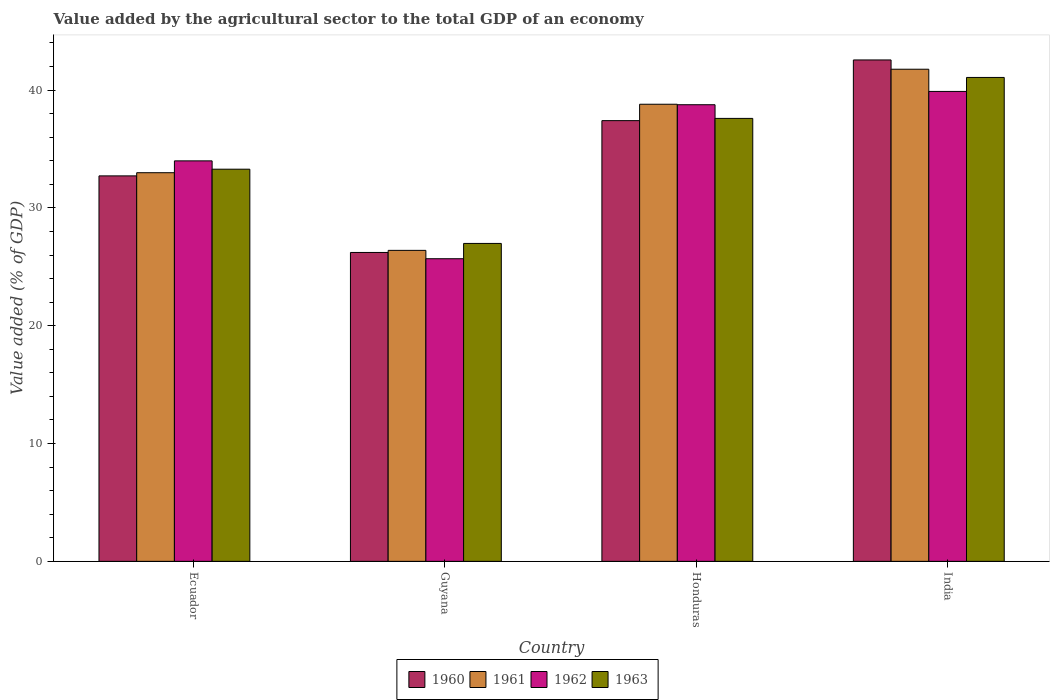How many different coloured bars are there?
Your response must be concise. 4. How many groups of bars are there?
Provide a short and direct response. 4. Are the number of bars on each tick of the X-axis equal?
Provide a succinct answer. Yes. How many bars are there on the 3rd tick from the left?
Make the answer very short. 4. What is the label of the 2nd group of bars from the left?
Provide a succinct answer. Guyana. What is the value added by the agricultural sector to the total GDP in 1963 in Ecuador?
Provide a short and direct response. 33.29. Across all countries, what is the maximum value added by the agricultural sector to the total GDP in 1963?
Your answer should be very brief. 41.08. Across all countries, what is the minimum value added by the agricultural sector to the total GDP in 1963?
Give a very brief answer. 26.99. In which country was the value added by the agricultural sector to the total GDP in 1962 maximum?
Provide a succinct answer. India. In which country was the value added by the agricultural sector to the total GDP in 1962 minimum?
Provide a short and direct response. Guyana. What is the total value added by the agricultural sector to the total GDP in 1962 in the graph?
Keep it short and to the point. 138.33. What is the difference between the value added by the agricultural sector to the total GDP in 1961 in Guyana and that in India?
Your answer should be very brief. -15.38. What is the difference between the value added by the agricultural sector to the total GDP in 1963 in Guyana and the value added by the agricultural sector to the total GDP in 1960 in Ecuador?
Keep it short and to the point. -5.73. What is the average value added by the agricultural sector to the total GDP in 1961 per country?
Make the answer very short. 34.99. What is the difference between the value added by the agricultural sector to the total GDP of/in 1961 and value added by the agricultural sector to the total GDP of/in 1960 in Honduras?
Your answer should be very brief. 1.39. What is the ratio of the value added by the agricultural sector to the total GDP in 1961 in Ecuador to that in India?
Your response must be concise. 0.79. Is the value added by the agricultural sector to the total GDP in 1962 in Guyana less than that in Honduras?
Your answer should be very brief. Yes. Is the difference between the value added by the agricultural sector to the total GDP in 1961 in Guyana and Honduras greater than the difference between the value added by the agricultural sector to the total GDP in 1960 in Guyana and Honduras?
Give a very brief answer. No. What is the difference between the highest and the second highest value added by the agricultural sector to the total GDP in 1961?
Your answer should be very brief. -8.78. What is the difference between the highest and the lowest value added by the agricultural sector to the total GDP in 1961?
Your answer should be very brief. 15.38. Is the sum of the value added by the agricultural sector to the total GDP in 1960 in Guyana and Honduras greater than the maximum value added by the agricultural sector to the total GDP in 1963 across all countries?
Ensure brevity in your answer.  Yes. Is it the case that in every country, the sum of the value added by the agricultural sector to the total GDP in 1961 and value added by the agricultural sector to the total GDP in 1963 is greater than the sum of value added by the agricultural sector to the total GDP in 1960 and value added by the agricultural sector to the total GDP in 1962?
Your answer should be compact. No. What does the 1st bar from the right in Honduras represents?
Offer a terse response. 1963. Is it the case that in every country, the sum of the value added by the agricultural sector to the total GDP in 1962 and value added by the agricultural sector to the total GDP in 1961 is greater than the value added by the agricultural sector to the total GDP in 1963?
Offer a terse response. Yes. Are all the bars in the graph horizontal?
Make the answer very short. No. How many countries are there in the graph?
Your response must be concise. 4. Are the values on the major ticks of Y-axis written in scientific E-notation?
Offer a very short reply. No. Does the graph contain grids?
Provide a succinct answer. No. Where does the legend appear in the graph?
Make the answer very short. Bottom center. What is the title of the graph?
Your answer should be very brief. Value added by the agricultural sector to the total GDP of an economy. Does "1986" appear as one of the legend labels in the graph?
Offer a very short reply. No. What is the label or title of the X-axis?
Keep it short and to the point. Country. What is the label or title of the Y-axis?
Keep it short and to the point. Value added (% of GDP). What is the Value added (% of GDP) of 1960 in Ecuador?
Your response must be concise. 32.72. What is the Value added (% of GDP) of 1961 in Ecuador?
Provide a short and direct response. 32.99. What is the Value added (% of GDP) in 1962 in Ecuador?
Your answer should be very brief. 33.99. What is the Value added (% of GDP) in 1963 in Ecuador?
Make the answer very short. 33.29. What is the Value added (% of GDP) in 1960 in Guyana?
Make the answer very short. 26.22. What is the Value added (% of GDP) of 1961 in Guyana?
Your response must be concise. 26.4. What is the Value added (% of GDP) in 1962 in Guyana?
Provide a succinct answer. 25.69. What is the Value added (% of GDP) of 1963 in Guyana?
Offer a very short reply. 26.99. What is the Value added (% of GDP) in 1960 in Honduras?
Your answer should be compact. 37.41. What is the Value added (% of GDP) in 1961 in Honduras?
Provide a succinct answer. 38.8. What is the Value added (% of GDP) in 1962 in Honduras?
Give a very brief answer. 38.76. What is the Value added (% of GDP) of 1963 in Honduras?
Make the answer very short. 37.6. What is the Value added (% of GDP) of 1960 in India?
Give a very brief answer. 42.56. What is the Value added (% of GDP) in 1961 in India?
Your response must be concise. 41.77. What is the Value added (% of GDP) in 1962 in India?
Your answer should be very brief. 39.89. What is the Value added (% of GDP) in 1963 in India?
Your response must be concise. 41.08. Across all countries, what is the maximum Value added (% of GDP) in 1960?
Your answer should be compact. 42.56. Across all countries, what is the maximum Value added (% of GDP) in 1961?
Make the answer very short. 41.77. Across all countries, what is the maximum Value added (% of GDP) of 1962?
Offer a terse response. 39.89. Across all countries, what is the maximum Value added (% of GDP) of 1963?
Provide a short and direct response. 41.08. Across all countries, what is the minimum Value added (% of GDP) in 1960?
Your response must be concise. 26.22. Across all countries, what is the minimum Value added (% of GDP) in 1961?
Offer a terse response. 26.4. Across all countries, what is the minimum Value added (% of GDP) of 1962?
Your response must be concise. 25.69. Across all countries, what is the minimum Value added (% of GDP) of 1963?
Provide a short and direct response. 26.99. What is the total Value added (% of GDP) of 1960 in the graph?
Keep it short and to the point. 138.91. What is the total Value added (% of GDP) of 1961 in the graph?
Your answer should be compact. 139.96. What is the total Value added (% of GDP) of 1962 in the graph?
Provide a short and direct response. 138.33. What is the total Value added (% of GDP) of 1963 in the graph?
Offer a very short reply. 138.95. What is the difference between the Value added (% of GDP) in 1960 in Ecuador and that in Guyana?
Your answer should be compact. 6.5. What is the difference between the Value added (% of GDP) of 1961 in Ecuador and that in Guyana?
Your answer should be compact. 6.59. What is the difference between the Value added (% of GDP) in 1962 in Ecuador and that in Guyana?
Your answer should be compact. 8.31. What is the difference between the Value added (% of GDP) in 1963 in Ecuador and that in Guyana?
Your answer should be very brief. 6.3. What is the difference between the Value added (% of GDP) of 1960 in Ecuador and that in Honduras?
Your answer should be very brief. -4.69. What is the difference between the Value added (% of GDP) in 1961 in Ecuador and that in Honduras?
Ensure brevity in your answer.  -5.81. What is the difference between the Value added (% of GDP) of 1962 in Ecuador and that in Honduras?
Keep it short and to the point. -4.77. What is the difference between the Value added (% of GDP) of 1963 in Ecuador and that in Honduras?
Your response must be concise. -4.31. What is the difference between the Value added (% of GDP) of 1960 in Ecuador and that in India?
Your answer should be very brief. -9.84. What is the difference between the Value added (% of GDP) of 1961 in Ecuador and that in India?
Ensure brevity in your answer.  -8.78. What is the difference between the Value added (% of GDP) of 1962 in Ecuador and that in India?
Provide a short and direct response. -5.89. What is the difference between the Value added (% of GDP) of 1963 in Ecuador and that in India?
Make the answer very short. -7.79. What is the difference between the Value added (% of GDP) of 1960 in Guyana and that in Honduras?
Your answer should be very brief. -11.19. What is the difference between the Value added (% of GDP) of 1961 in Guyana and that in Honduras?
Your answer should be very brief. -12.4. What is the difference between the Value added (% of GDP) of 1962 in Guyana and that in Honduras?
Your answer should be compact. -13.07. What is the difference between the Value added (% of GDP) in 1963 in Guyana and that in Honduras?
Make the answer very short. -10.61. What is the difference between the Value added (% of GDP) of 1960 in Guyana and that in India?
Make the answer very short. -16.34. What is the difference between the Value added (% of GDP) of 1961 in Guyana and that in India?
Your response must be concise. -15.38. What is the difference between the Value added (% of GDP) in 1962 in Guyana and that in India?
Your response must be concise. -14.2. What is the difference between the Value added (% of GDP) of 1963 in Guyana and that in India?
Provide a succinct answer. -14.09. What is the difference between the Value added (% of GDP) of 1960 in Honduras and that in India?
Offer a very short reply. -5.15. What is the difference between the Value added (% of GDP) in 1961 in Honduras and that in India?
Your answer should be very brief. -2.97. What is the difference between the Value added (% of GDP) in 1962 in Honduras and that in India?
Offer a terse response. -1.13. What is the difference between the Value added (% of GDP) of 1963 in Honduras and that in India?
Offer a very short reply. -3.48. What is the difference between the Value added (% of GDP) in 1960 in Ecuador and the Value added (% of GDP) in 1961 in Guyana?
Provide a short and direct response. 6.32. What is the difference between the Value added (% of GDP) of 1960 in Ecuador and the Value added (% of GDP) of 1962 in Guyana?
Your response must be concise. 7.03. What is the difference between the Value added (% of GDP) of 1960 in Ecuador and the Value added (% of GDP) of 1963 in Guyana?
Keep it short and to the point. 5.73. What is the difference between the Value added (% of GDP) in 1961 in Ecuador and the Value added (% of GDP) in 1962 in Guyana?
Your answer should be compact. 7.3. What is the difference between the Value added (% of GDP) in 1961 in Ecuador and the Value added (% of GDP) in 1963 in Guyana?
Your response must be concise. 6. What is the difference between the Value added (% of GDP) of 1962 in Ecuador and the Value added (% of GDP) of 1963 in Guyana?
Offer a terse response. 7.01. What is the difference between the Value added (% of GDP) in 1960 in Ecuador and the Value added (% of GDP) in 1961 in Honduras?
Your response must be concise. -6.08. What is the difference between the Value added (% of GDP) in 1960 in Ecuador and the Value added (% of GDP) in 1962 in Honduras?
Your response must be concise. -6.04. What is the difference between the Value added (% of GDP) of 1960 in Ecuador and the Value added (% of GDP) of 1963 in Honduras?
Provide a short and direct response. -4.88. What is the difference between the Value added (% of GDP) of 1961 in Ecuador and the Value added (% of GDP) of 1962 in Honduras?
Your answer should be compact. -5.77. What is the difference between the Value added (% of GDP) in 1961 in Ecuador and the Value added (% of GDP) in 1963 in Honduras?
Make the answer very short. -4.61. What is the difference between the Value added (% of GDP) of 1962 in Ecuador and the Value added (% of GDP) of 1963 in Honduras?
Provide a short and direct response. -3.61. What is the difference between the Value added (% of GDP) of 1960 in Ecuador and the Value added (% of GDP) of 1961 in India?
Your answer should be very brief. -9.05. What is the difference between the Value added (% of GDP) in 1960 in Ecuador and the Value added (% of GDP) in 1962 in India?
Provide a succinct answer. -7.17. What is the difference between the Value added (% of GDP) of 1960 in Ecuador and the Value added (% of GDP) of 1963 in India?
Your response must be concise. -8.36. What is the difference between the Value added (% of GDP) of 1961 in Ecuador and the Value added (% of GDP) of 1962 in India?
Provide a short and direct response. -6.9. What is the difference between the Value added (% of GDP) in 1961 in Ecuador and the Value added (% of GDP) in 1963 in India?
Offer a terse response. -8.09. What is the difference between the Value added (% of GDP) in 1962 in Ecuador and the Value added (% of GDP) in 1963 in India?
Ensure brevity in your answer.  -7.08. What is the difference between the Value added (% of GDP) of 1960 in Guyana and the Value added (% of GDP) of 1961 in Honduras?
Give a very brief answer. -12.58. What is the difference between the Value added (% of GDP) in 1960 in Guyana and the Value added (% of GDP) in 1962 in Honduras?
Offer a very short reply. -12.54. What is the difference between the Value added (% of GDP) of 1960 in Guyana and the Value added (% of GDP) of 1963 in Honduras?
Offer a very short reply. -11.38. What is the difference between the Value added (% of GDP) of 1961 in Guyana and the Value added (% of GDP) of 1962 in Honduras?
Provide a succinct answer. -12.36. What is the difference between the Value added (% of GDP) in 1961 in Guyana and the Value added (% of GDP) in 1963 in Honduras?
Give a very brief answer. -11.2. What is the difference between the Value added (% of GDP) of 1962 in Guyana and the Value added (% of GDP) of 1963 in Honduras?
Your answer should be very brief. -11.91. What is the difference between the Value added (% of GDP) of 1960 in Guyana and the Value added (% of GDP) of 1961 in India?
Make the answer very short. -15.55. What is the difference between the Value added (% of GDP) in 1960 in Guyana and the Value added (% of GDP) in 1962 in India?
Your answer should be very brief. -13.67. What is the difference between the Value added (% of GDP) in 1960 in Guyana and the Value added (% of GDP) in 1963 in India?
Make the answer very short. -14.86. What is the difference between the Value added (% of GDP) in 1961 in Guyana and the Value added (% of GDP) in 1962 in India?
Ensure brevity in your answer.  -13.49. What is the difference between the Value added (% of GDP) of 1961 in Guyana and the Value added (% of GDP) of 1963 in India?
Provide a succinct answer. -14.68. What is the difference between the Value added (% of GDP) in 1962 in Guyana and the Value added (% of GDP) in 1963 in India?
Ensure brevity in your answer.  -15.39. What is the difference between the Value added (% of GDP) of 1960 in Honduras and the Value added (% of GDP) of 1961 in India?
Provide a short and direct response. -4.36. What is the difference between the Value added (% of GDP) of 1960 in Honduras and the Value added (% of GDP) of 1962 in India?
Offer a terse response. -2.48. What is the difference between the Value added (% of GDP) of 1960 in Honduras and the Value added (% of GDP) of 1963 in India?
Offer a terse response. -3.67. What is the difference between the Value added (% of GDP) in 1961 in Honduras and the Value added (% of GDP) in 1962 in India?
Provide a succinct answer. -1.09. What is the difference between the Value added (% of GDP) of 1961 in Honduras and the Value added (% of GDP) of 1963 in India?
Your answer should be compact. -2.27. What is the difference between the Value added (% of GDP) in 1962 in Honduras and the Value added (% of GDP) in 1963 in India?
Make the answer very short. -2.32. What is the average Value added (% of GDP) of 1960 per country?
Provide a short and direct response. 34.73. What is the average Value added (% of GDP) in 1961 per country?
Your response must be concise. 34.99. What is the average Value added (% of GDP) of 1962 per country?
Provide a succinct answer. 34.58. What is the average Value added (% of GDP) in 1963 per country?
Ensure brevity in your answer.  34.74. What is the difference between the Value added (% of GDP) in 1960 and Value added (% of GDP) in 1961 in Ecuador?
Provide a succinct answer. -0.27. What is the difference between the Value added (% of GDP) of 1960 and Value added (% of GDP) of 1962 in Ecuador?
Keep it short and to the point. -1.27. What is the difference between the Value added (% of GDP) of 1960 and Value added (% of GDP) of 1963 in Ecuador?
Ensure brevity in your answer.  -0.57. What is the difference between the Value added (% of GDP) in 1961 and Value added (% of GDP) in 1962 in Ecuador?
Give a very brief answer. -1. What is the difference between the Value added (% of GDP) in 1961 and Value added (% of GDP) in 1963 in Ecuador?
Provide a succinct answer. -0.3. What is the difference between the Value added (% of GDP) of 1962 and Value added (% of GDP) of 1963 in Ecuador?
Your answer should be very brief. 0.71. What is the difference between the Value added (% of GDP) of 1960 and Value added (% of GDP) of 1961 in Guyana?
Your response must be concise. -0.18. What is the difference between the Value added (% of GDP) of 1960 and Value added (% of GDP) of 1962 in Guyana?
Your answer should be very brief. 0.53. What is the difference between the Value added (% of GDP) in 1960 and Value added (% of GDP) in 1963 in Guyana?
Make the answer very short. -0.77. What is the difference between the Value added (% of GDP) of 1961 and Value added (% of GDP) of 1962 in Guyana?
Provide a succinct answer. 0.71. What is the difference between the Value added (% of GDP) in 1961 and Value added (% of GDP) in 1963 in Guyana?
Offer a very short reply. -0.59. What is the difference between the Value added (% of GDP) in 1962 and Value added (% of GDP) in 1963 in Guyana?
Provide a succinct answer. -1.3. What is the difference between the Value added (% of GDP) in 1960 and Value added (% of GDP) in 1961 in Honduras?
Your response must be concise. -1.39. What is the difference between the Value added (% of GDP) of 1960 and Value added (% of GDP) of 1962 in Honduras?
Give a very brief answer. -1.35. What is the difference between the Value added (% of GDP) in 1960 and Value added (% of GDP) in 1963 in Honduras?
Your answer should be very brief. -0.19. What is the difference between the Value added (% of GDP) of 1961 and Value added (% of GDP) of 1962 in Honduras?
Your response must be concise. 0.04. What is the difference between the Value added (% of GDP) of 1961 and Value added (% of GDP) of 1963 in Honduras?
Give a very brief answer. 1.2. What is the difference between the Value added (% of GDP) of 1962 and Value added (% of GDP) of 1963 in Honduras?
Your answer should be very brief. 1.16. What is the difference between the Value added (% of GDP) in 1960 and Value added (% of GDP) in 1961 in India?
Your response must be concise. 0.79. What is the difference between the Value added (% of GDP) of 1960 and Value added (% of GDP) of 1962 in India?
Offer a terse response. 2.67. What is the difference between the Value added (% of GDP) of 1960 and Value added (% of GDP) of 1963 in India?
Give a very brief answer. 1.49. What is the difference between the Value added (% of GDP) of 1961 and Value added (% of GDP) of 1962 in India?
Offer a terse response. 1.89. What is the difference between the Value added (% of GDP) of 1961 and Value added (% of GDP) of 1963 in India?
Keep it short and to the point. 0.7. What is the difference between the Value added (% of GDP) in 1962 and Value added (% of GDP) in 1963 in India?
Give a very brief answer. -1.19. What is the ratio of the Value added (% of GDP) of 1960 in Ecuador to that in Guyana?
Ensure brevity in your answer.  1.25. What is the ratio of the Value added (% of GDP) of 1961 in Ecuador to that in Guyana?
Make the answer very short. 1.25. What is the ratio of the Value added (% of GDP) in 1962 in Ecuador to that in Guyana?
Keep it short and to the point. 1.32. What is the ratio of the Value added (% of GDP) of 1963 in Ecuador to that in Guyana?
Offer a terse response. 1.23. What is the ratio of the Value added (% of GDP) in 1960 in Ecuador to that in Honduras?
Give a very brief answer. 0.87. What is the ratio of the Value added (% of GDP) of 1961 in Ecuador to that in Honduras?
Give a very brief answer. 0.85. What is the ratio of the Value added (% of GDP) of 1962 in Ecuador to that in Honduras?
Your response must be concise. 0.88. What is the ratio of the Value added (% of GDP) in 1963 in Ecuador to that in Honduras?
Your response must be concise. 0.89. What is the ratio of the Value added (% of GDP) in 1960 in Ecuador to that in India?
Provide a short and direct response. 0.77. What is the ratio of the Value added (% of GDP) of 1961 in Ecuador to that in India?
Keep it short and to the point. 0.79. What is the ratio of the Value added (% of GDP) of 1962 in Ecuador to that in India?
Make the answer very short. 0.85. What is the ratio of the Value added (% of GDP) of 1963 in Ecuador to that in India?
Your response must be concise. 0.81. What is the ratio of the Value added (% of GDP) of 1960 in Guyana to that in Honduras?
Provide a succinct answer. 0.7. What is the ratio of the Value added (% of GDP) of 1961 in Guyana to that in Honduras?
Keep it short and to the point. 0.68. What is the ratio of the Value added (% of GDP) in 1962 in Guyana to that in Honduras?
Keep it short and to the point. 0.66. What is the ratio of the Value added (% of GDP) in 1963 in Guyana to that in Honduras?
Give a very brief answer. 0.72. What is the ratio of the Value added (% of GDP) in 1960 in Guyana to that in India?
Your response must be concise. 0.62. What is the ratio of the Value added (% of GDP) of 1961 in Guyana to that in India?
Your answer should be compact. 0.63. What is the ratio of the Value added (% of GDP) of 1962 in Guyana to that in India?
Your response must be concise. 0.64. What is the ratio of the Value added (% of GDP) in 1963 in Guyana to that in India?
Your answer should be compact. 0.66. What is the ratio of the Value added (% of GDP) in 1960 in Honduras to that in India?
Your response must be concise. 0.88. What is the ratio of the Value added (% of GDP) of 1961 in Honduras to that in India?
Provide a short and direct response. 0.93. What is the ratio of the Value added (% of GDP) of 1962 in Honduras to that in India?
Offer a very short reply. 0.97. What is the ratio of the Value added (% of GDP) in 1963 in Honduras to that in India?
Offer a very short reply. 0.92. What is the difference between the highest and the second highest Value added (% of GDP) in 1960?
Make the answer very short. 5.15. What is the difference between the highest and the second highest Value added (% of GDP) in 1961?
Provide a succinct answer. 2.97. What is the difference between the highest and the second highest Value added (% of GDP) of 1962?
Your answer should be compact. 1.13. What is the difference between the highest and the second highest Value added (% of GDP) in 1963?
Your answer should be very brief. 3.48. What is the difference between the highest and the lowest Value added (% of GDP) of 1960?
Make the answer very short. 16.34. What is the difference between the highest and the lowest Value added (% of GDP) in 1961?
Keep it short and to the point. 15.38. What is the difference between the highest and the lowest Value added (% of GDP) of 1962?
Give a very brief answer. 14.2. What is the difference between the highest and the lowest Value added (% of GDP) in 1963?
Give a very brief answer. 14.09. 